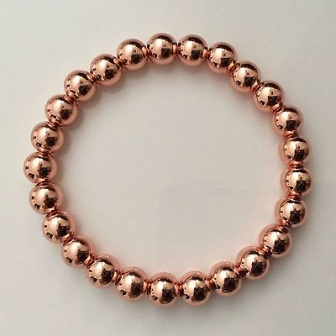What might be the significance or meaning of a bracelet like this? A bracelet like this could hold various meanings depending on the context. Given its copper color, it might be associated with attributes such as energy balance, healing, and wellness, as copper is often believed to have therapeutic properties. The circular shape, seen as a universal symbol of completeness and unity, could represent continuity, wholeness, or eternal friendship. This kind of bracelet could be given as a meaningful gift, symbolizing enduring bonds and well-wishes for the wearer's health and happiness. Imagine this bracelet has a magical property. What kind of power would it have? Imagine this bracelet possesses the power of temporal manipulation. Each copper bead represents a moment in time, and by rotating the bracelet, the wearer can shift backward or forward through these moments. To those unaware, it appears as an ordinary piece of jewelry, but to the bearer, it is a key to reliving cherished memories, altering past regrets, or glimpsing future possibilities. This enchantment comes with a caveat: substantial changes to the timeline could result in unforeseen consequences, making the power both a gift and a responsibility. 